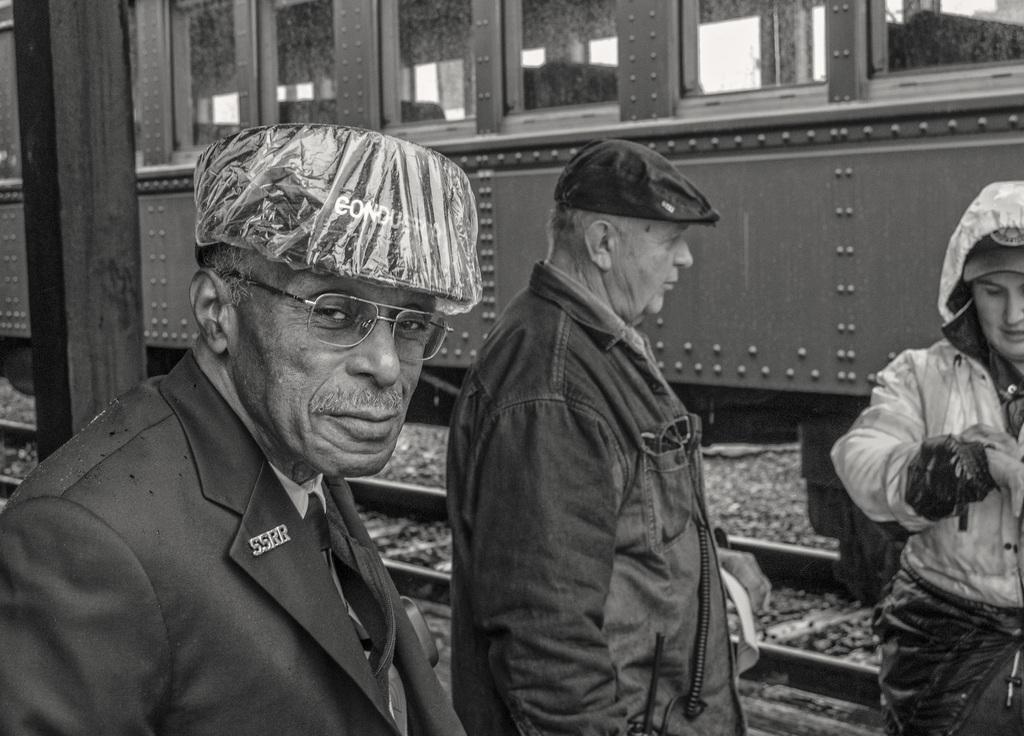In one or two sentences, can you explain what this image depicts? This is a black and white image where we can see this person wearing blazer, tie, spectacles and cap is standing. Here we can see these two persons are also standing. In the background, we can see wooden pillar and a train on the railway track. 